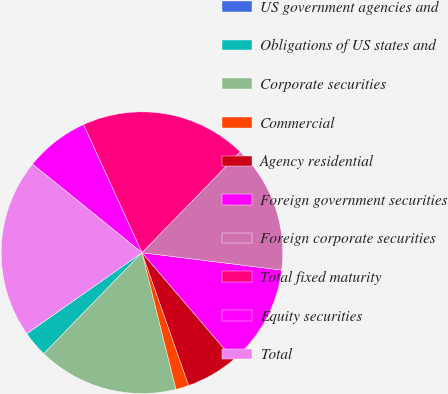Convert chart to OTSL. <chart><loc_0><loc_0><loc_500><loc_500><pie_chart><fcel>US government agencies and<fcel>Obligations of US states and<fcel>Corporate securities<fcel>Commercial<fcel>Agency residential<fcel>Foreign government securities<fcel>Foreign corporate securities<fcel>Total fixed maturity<fcel>Equity securities<fcel>Total<nl><fcel>0.03%<fcel>2.96%<fcel>16.16%<fcel>1.49%<fcel>5.89%<fcel>11.76%<fcel>14.69%<fcel>19.09%<fcel>7.36%<fcel>20.56%<nl></chart> 